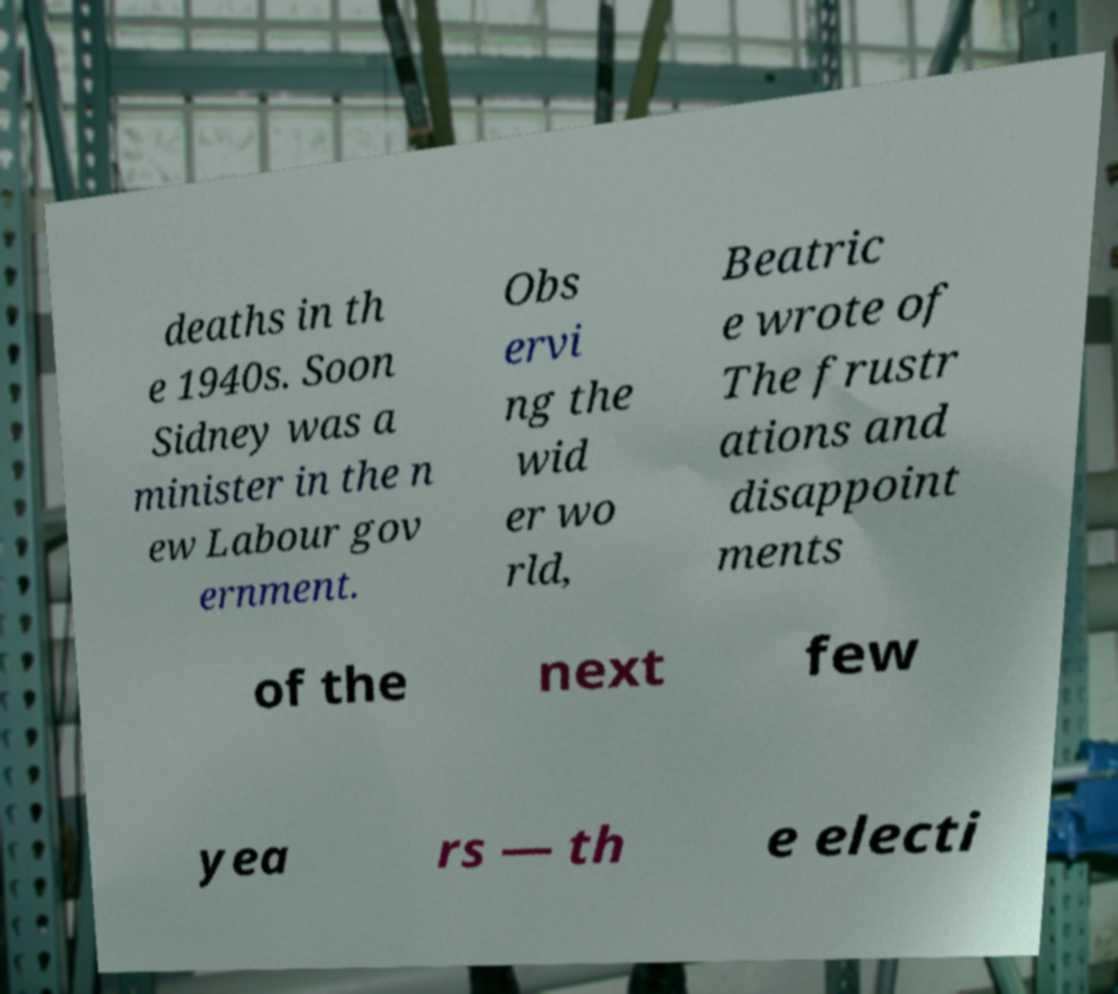I need the written content from this picture converted into text. Can you do that? deaths in th e 1940s. Soon Sidney was a minister in the n ew Labour gov ernment. Obs ervi ng the wid er wo rld, Beatric e wrote of The frustr ations and disappoint ments of the next few yea rs — th e electi 